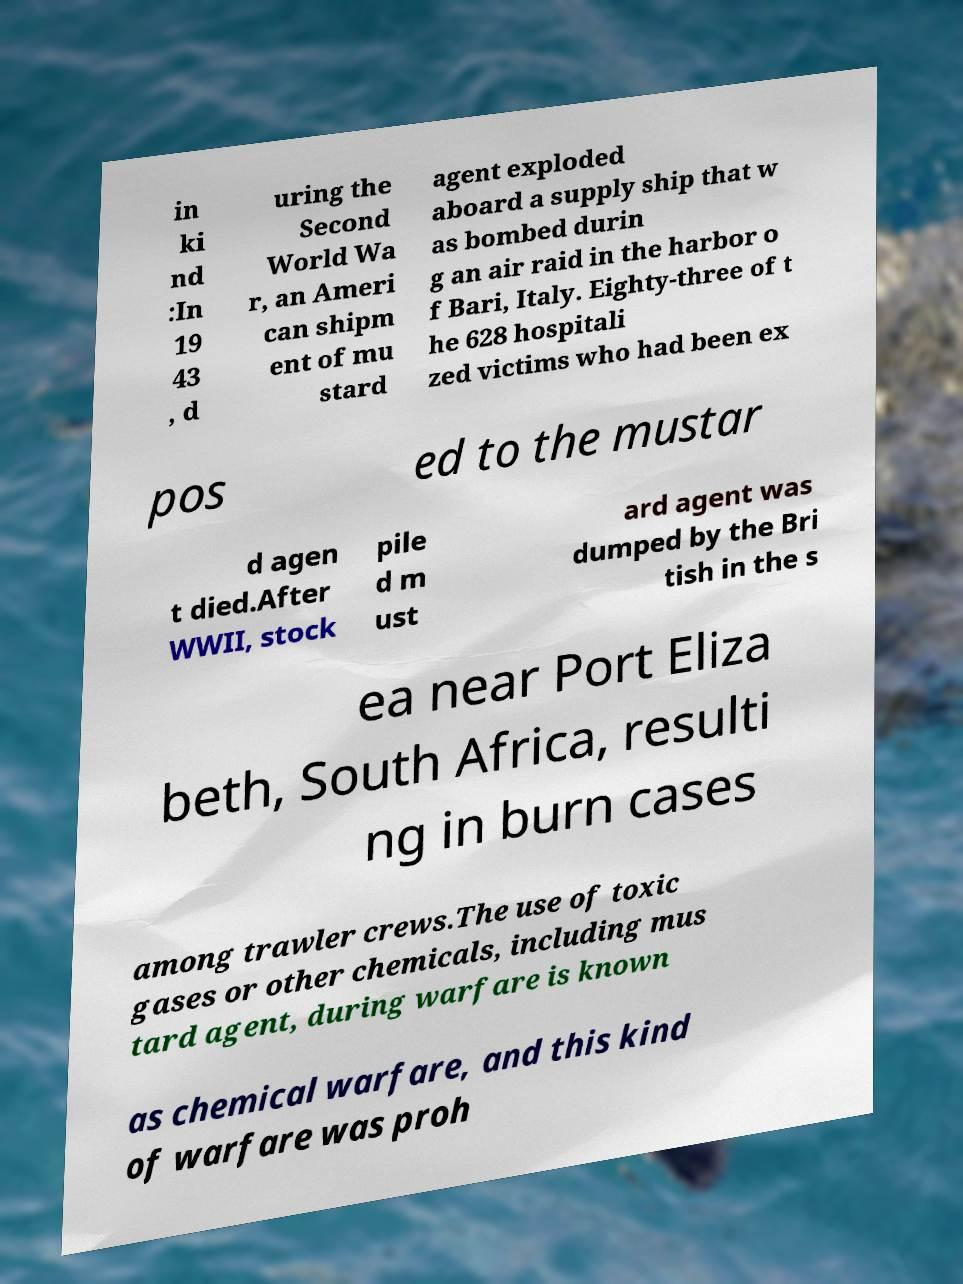Could you extract and type out the text from this image? in ki nd :In 19 43 , d uring the Second World Wa r, an Ameri can shipm ent of mu stard agent exploded aboard a supply ship that w as bombed durin g an air raid in the harbor o f Bari, Italy. Eighty-three of t he 628 hospitali zed victims who had been ex pos ed to the mustar d agen t died.After WWII, stock pile d m ust ard agent was dumped by the Bri tish in the s ea near Port Eliza beth, South Africa, resulti ng in burn cases among trawler crews.The use of toxic gases or other chemicals, including mus tard agent, during warfare is known as chemical warfare, and this kind of warfare was proh 